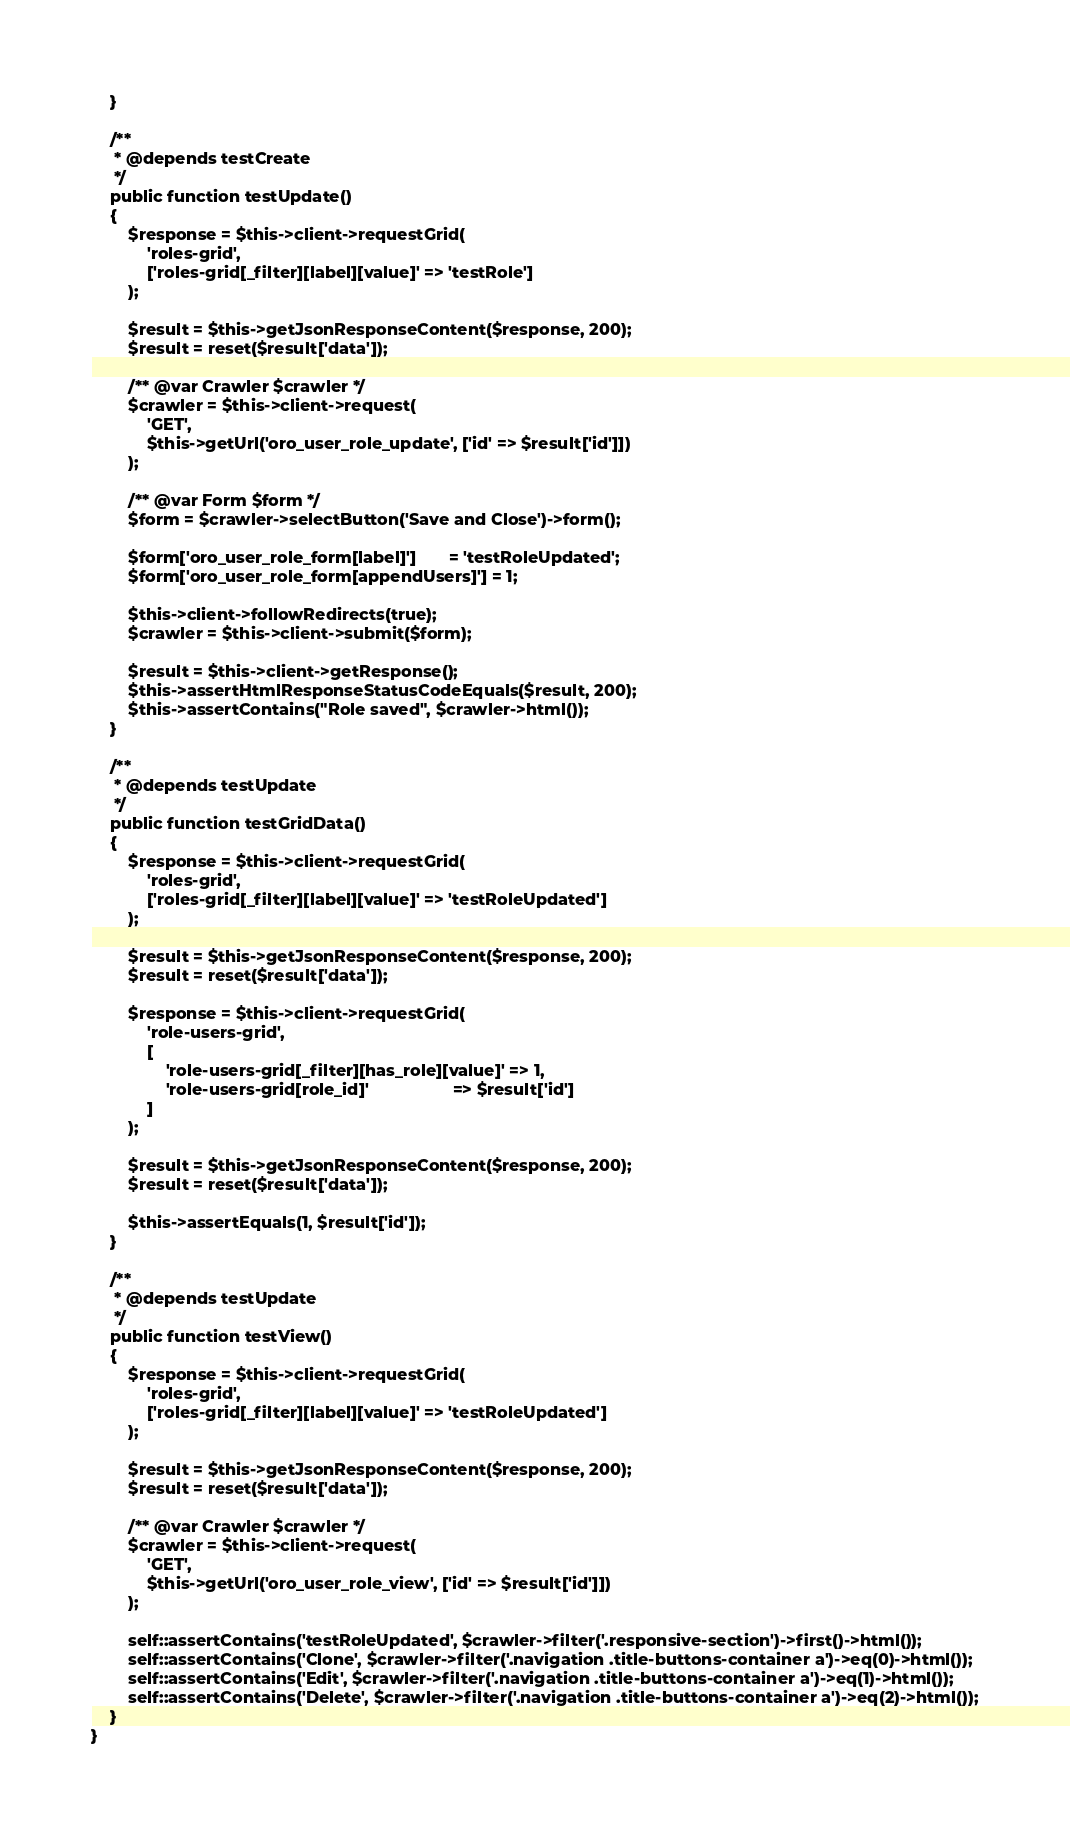<code> <loc_0><loc_0><loc_500><loc_500><_PHP_>    }

    /**
     * @depends testCreate
     */
    public function testUpdate()
    {
        $response = $this->client->requestGrid(
            'roles-grid',
            ['roles-grid[_filter][label][value]' => 'testRole']
        );

        $result = $this->getJsonResponseContent($response, 200);
        $result = reset($result['data']);

        /** @var Crawler $crawler */
        $crawler = $this->client->request(
            'GET',
            $this->getUrl('oro_user_role_update', ['id' => $result['id']])
        );

        /** @var Form $form */
        $form = $crawler->selectButton('Save and Close')->form();

        $form['oro_user_role_form[label]']       = 'testRoleUpdated';
        $form['oro_user_role_form[appendUsers]'] = 1;

        $this->client->followRedirects(true);
        $crawler = $this->client->submit($form);

        $result = $this->client->getResponse();
        $this->assertHtmlResponseStatusCodeEquals($result, 200);
        $this->assertContains("Role saved", $crawler->html());
    }

    /**
     * @depends testUpdate
     */
    public function testGridData()
    {
        $response = $this->client->requestGrid(
            'roles-grid',
            ['roles-grid[_filter][label][value]' => 'testRoleUpdated']
        );

        $result = $this->getJsonResponseContent($response, 200);
        $result = reset($result['data']);

        $response = $this->client->requestGrid(
            'role-users-grid',
            [
                'role-users-grid[_filter][has_role][value]' => 1,
                'role-users-grid[role_id]'                  => $result['id']
            ]
        );

        $result = $this->getJsonResponseContent($response, 200);
        $result = reset($result['data']);

        $this->assertEquals(1, $result['id']);
    }

    /**
     * @depends testUpdate
     */
    public function testView()
    {
        $response = $this->client->requestGrid(
            'roles-grid',
            ['roles-grid[_filter][label][value]' => 'testRoleUpdated']
        );

        $result = $this->getJsonResponseContent($response, 200);
        $result = reset($result['data']);

        /** @var Crawler $crawler */
        $crawler = $this->client->request(
            'GET',
            $this->getUrl('oro_user_role_view', ['id' => $result['id']])
        );

        self::assertContains('testRoleUpdated', $crawler->filter('.responsive-section')->first()->html());
        self::assertContains('Clone', $crawler->filter('.navigation .title-buttons-container a')->eq(0)->html());
        self::assertContains('Edit', $crawler->filter('.navigation .title-buttons-container a')->eq(1)->html());
        self::assertContains('Delete', $crawler->filter('.navigation .title-buttons-container a')->eq(2)->html());
    }
}
</code> 